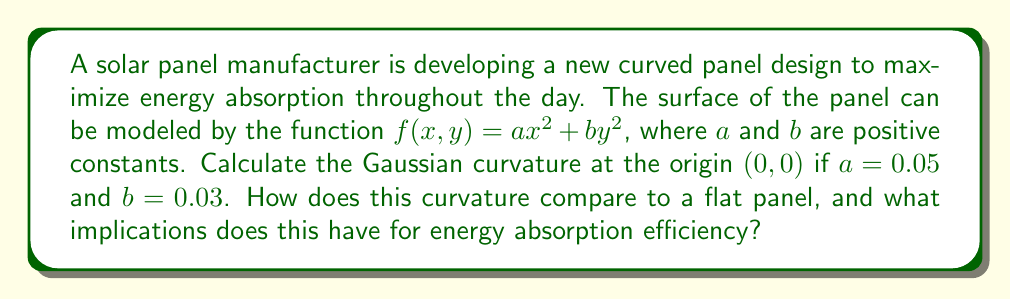Could you help me with this problem? To solve this problem, we'll follow these steps:

1) The Gaussian curvature $K$ of a surface $z = f(x,y)$ at a point $(x,y)$ is given by:

   $$K = \frac{f_{xx}f_{yy} - f_{xy}^2}{(1 + f_x^2 + f_y^2)^2}$$

   where subscripts denote partial derivatives.

2) For our surface $f(x,y) = ax^2 + by^2$, we need to calculate:
   
   $f_x = 2ax$
   $f_y = 2by$
   $f_{xx} = 2a$
   $f_{yy} = 2b$
   $f_{xy} = 0$

3) At the origin $(0,0)$:
   
   $f_x = f_y = 0$
   $f_{xx} = 2a = 2(0.05) = 0.1$
   $f_{yy} = 2b = 2(0.03) = 0.06$
   $f_{xy} = 0$

4) Substituting into the Gaussian curvature formula:

   $$K = \frac{(0.1)(0.06) - 0^2}{(1 + 0^2 + 0^2)^2} = \frac{0.006}{1} = 0.006$$

5) The Gaussian curvature at the origin is 0.006.

6) For a flat panel, the Gaussian curvature would be 0 everywhere.

7) The positive curvature indicates that the panel is dome-shaped at the origin. This curvature allows the panel to capture sunlight from various angles throughout the day, potentially increasing energy absorption efficiency compared to a flat panel.
Answer: $K = 0.006$; positive curvature implies improved energy absorption efficiency. 